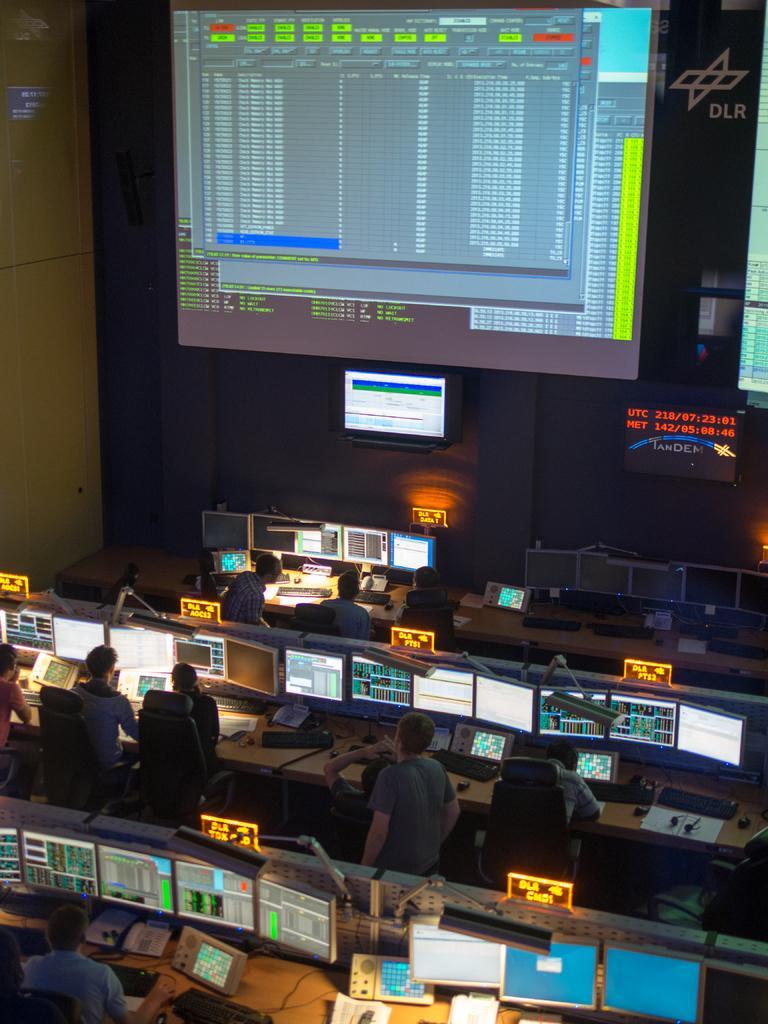Please provide a concise description of this image. In this image i can see there is a big screen visible on the middle and there are the tables seen, on the table , there are the systems kept on the table ,there are the persons standing and sitting on the chairs. 